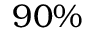Convert formula to latex. <formula><loc_0><loc_0><loc_500><loc_500>9 0 \%</formula> 